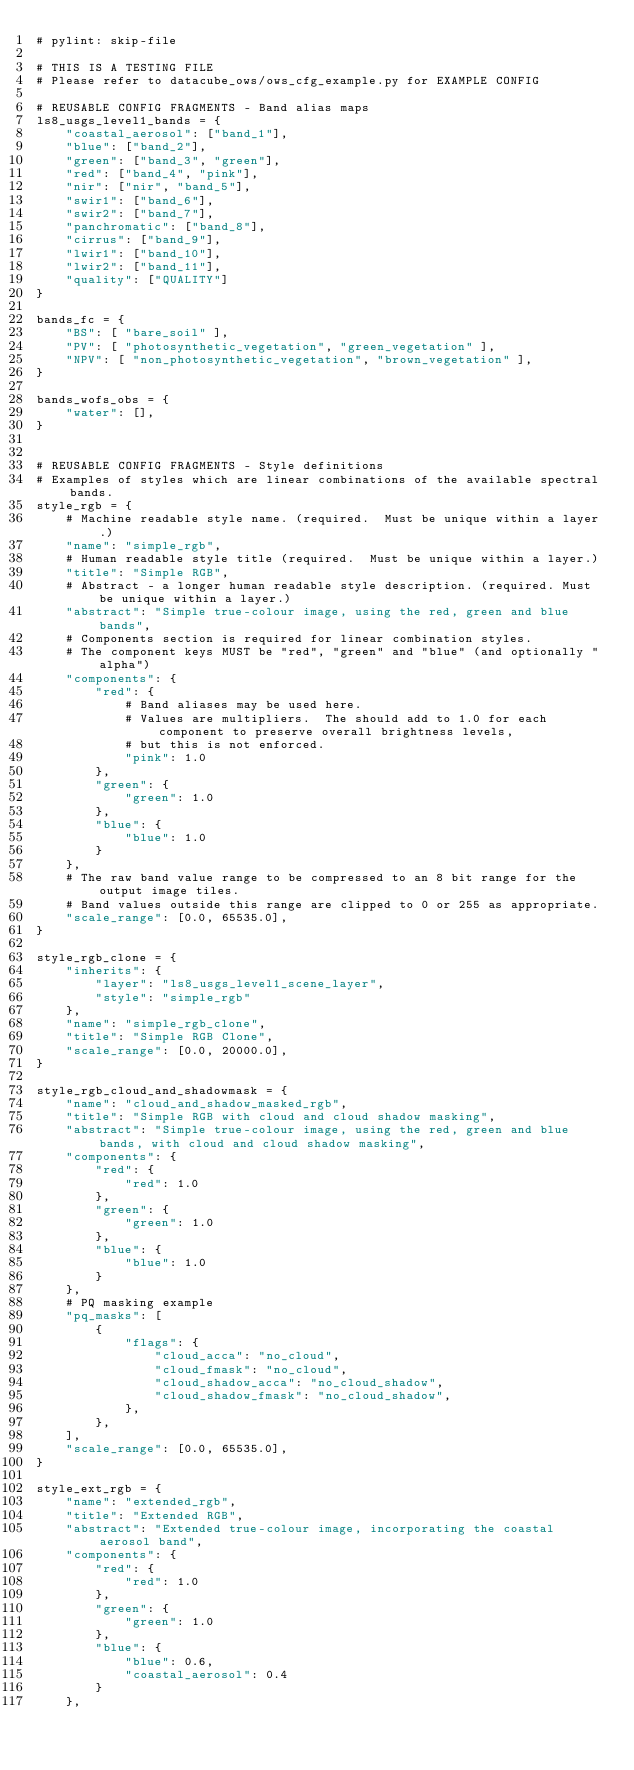<code> <loc_0><loc_0><loc_500><loc_500><_Python_># pylint: skip-file

# THIS IS A TESTING FILE
# Please refer to datacube_ows/ows_cfg_example.py for EXAMPLE CONFIG

# REUSABLE CONFIG FRAGMENTS - Band alias maps
ls8_usgs_level1_bands = {
    "coastal_aerosol": ["band_1"],
    "blue": ["band_2"],
    "green": ["band_3", "green"],
    "red": ["band_4", "pink"],
    "nir": ["nir", "band_5"],
    "swir1": ["band_6"],
    "swir2": ["band_7"],
    "panchromatic": ["band_8"],
    "cirrus": ["band_9"],
    "lwir1": ["band_10"],
    "lwir2": ["band_11"],
    "quality": ["QUALITY"]
}

bands_fc = {
    "BS": [ "bare_soil" ],
    "PV": [ "photosynthetic_vegetation", "green_vegetation" ],
    "NPV": [ "non_photosynthetic_vegetation", "brown_vegetation" ],
}

bands_wofs_obs = {
    "water": [],
}


# REUSABLE CONFIG FRAGMENTS - Style definitions
# Examples of styles which are linear combinations of the available spectral bands.
style_rgb = {
    # Machine readable style name. (required.  Must be unique within a layer.)
    "name": "simple_rgb",
    # Human readable style title (required.  Must be unique within a layer.)
    "title": "Simple RGB",
    # Abstract - a longer human readable style description. (required. Must be unique within a layer.)
    "abstract": "Simple true-colour image, using the red, green and blue bands",
    # Components section is required for linear combination styles.
    # The component keys MUST be "red", "green" and "blue" (and optionally "alpha")
    "components": {
        "red": {
            # Band aliases may be used here.
            # Values are multipliers.  The should add to 1.0 for each component to preserve overall brightness levels,
            # but this is not enforced.
            "pink": 1.0
        },
        "green": {
            "green": 1.0
        },
        "blue": {
            "blue": 1.0
        }
    },
    # The raw band value range to be compressed to an 8 bit range for the output image tiles.
    # Band values outside this range are clipped to 0 or 255 as appropriate.
    "scale_range": [0.0, 65535.0],
}

style_rgb_clone = {
    "inherits": {
        "layer": "ls8_usgs_level1_scene_layer",
        "style": "simple_rgb"
    },
    "name": "simple_rgb_clone",
    "title": "Simple RGB Clone",
    "scale_range": [0.0, 20000.0],
}

style_rgb_cloud_and_shadowmask = {
    "name": "cloud_and_shadow_masked_rgb",
    "title": "Simple RGB with cloud and cloud shadow masking",
    "abstract": "Simple true-colour image, using the red, green and blue bands, with cloud and cloud shadow masking",
    "components": {
        "red": {
            "red": 1.0
        },
        "green": {
            "green": 1.0
        },
        "blue": {
            "blue": 1.0
        }
    },
    # PQ masking example
    "pq_masks": [
        {
            "flags": {
                "cloud_acca": "no_cloud",
                "cloud_fmask": "no_cloud",
                "cloud_shadow_acca": "no_cloud_shadow",
                "cloud_shadow_fmask": "no_cloud_shadow",
            },
        },
    ],
    "scale_range": [0.0, 65535.0],
}

style_ext_rgb = {
    "name": "extended_rgb",
    "title": "Extended RGB",
    "abstract": "Extended true-colour image, incorporating the coastal aerosol band",
    "components": {
        "red": {
            "red": 1.0
        },
        "green": {
            "green": 1.0
        },
        "blue": {
            "blue": 0.6,
            "coastal_aerosol": 0.4
        }
    },</code> 